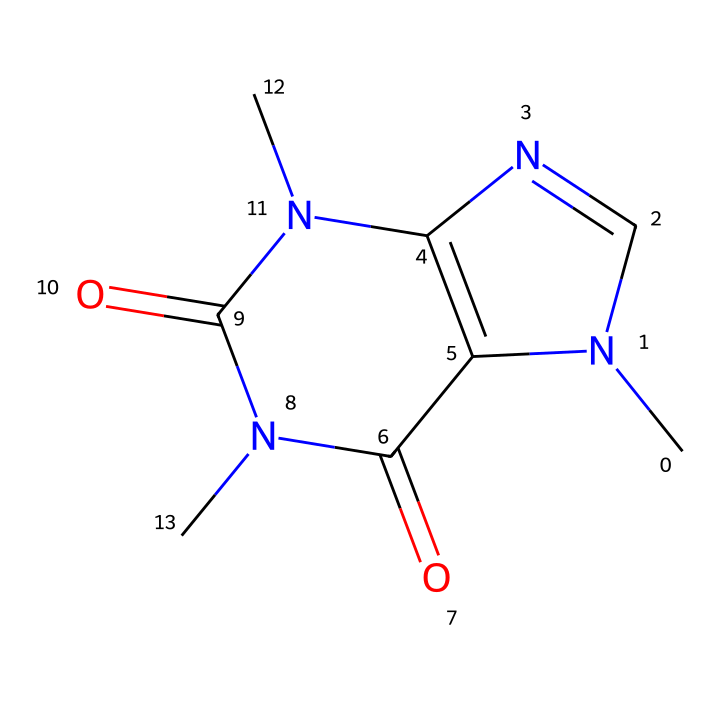What is the molecular formula of caffeine? By analyzing the provided SMILES representation, we can determine the molecular formula by counting the number of each type of atom present. The SMILES indicates there are 8 carbon atoms (C), 10 hydrogen atoms (H), 4 nitrogen atoms (N), and 2 oxygen atoms (O), resulting in the formula C8H10N4O2.
Answer: C8H10N4O2 How many nitrogen atoms are present in caffeine? The SMILES structure indicates that there are four occurrences of the letter 'N', which corresponds to nitrogen atoms within the molecule. Thus, we can conclude that there are four nitrogen atoms present in the chemical structure of caffeine.
Answer: 4 How many rings are present in the caffeine structure? Upon examining the structure, we can identify two rings in the caffeine's chemical framework. Each part of the SMILES representation that connects through atoms typically indicates a cyclical structure. Therefore, the presence of two juxtaposed nitrogen atoms confirms the existence of two rings.
Answer: 2 What functional groups are indicated in the caffeine structure? In the SMILES representation, we see multiple carbon atoms adjacent to nitrogen and oxygen, suggesting the presence of amide functional groups (due to the carbonyls next to nitrogen). The identification of C=O (carbonyl) adjacent to the N indicates that functional groups include amides.
Answer: amides Does caffeine have any oxidizing properties? Though caffeine itself is primarily known as a stimulant, it does not possess significant oxidizing properties; it does not readily accept electrons or increase the oxidation state of other substances. Instead, it acts mainly as a central nervous system stimulant.
Answer: no 